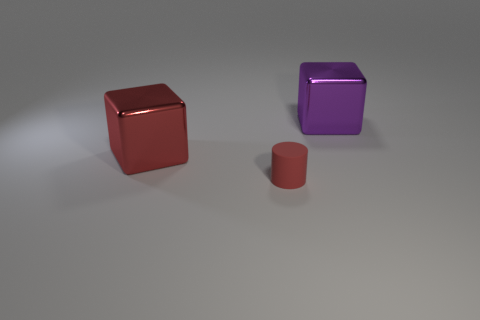There is a red object that is the same size as the purple shiny block; what is its shape?
Offer a terse response. Cube. There is a metallic object that is to the right of the big red block; is its size the same as the cylinder that is to the left of the purple block?
Ensure brevity in your answer.  No. How many purple matte cylinders are there?
Keep it short and to the point. 0. How big is the matte cylinder that is on the right side of the metal cube on the left side of the big metallic cube on the right side of the red metallic thing?
Ensure brevity in your answer.  Small. Is there any other thing that is the same size as the rubber cylinder?
Your answer should be very brief. No. What number of cylinders are in front of the big purple cube?
Provide a short and direct response. 1. Are there the same number of metal objects that are to the right of the red cube and big purple shiny blocks?
Offer a terse response. Yes. What number of things are either big cubes or brown rubber blocks?
Your answer should be compact. 2. Are there any other things that have the same shape as the small red thing?
Offer a very short reply. No. What shape is the tiny rubber object that is in front of the metallic block behind the large red block?
Provide a short and direct response. Cylinder. 